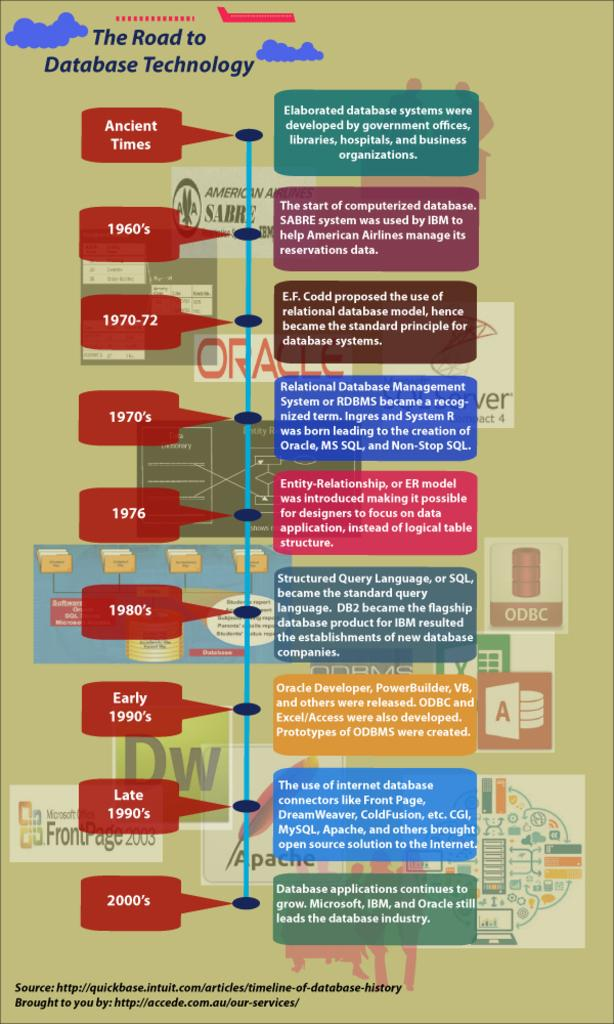<image>
Relay a brief, clear account of the picture shown. Informational graph poster titled the road to database technology. 